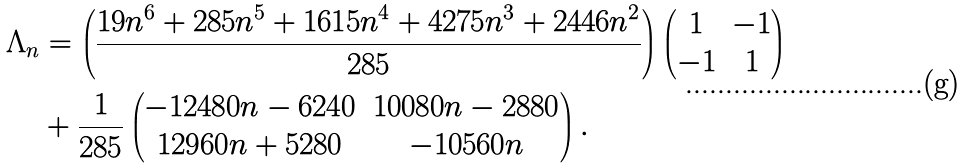Convert formula to latex. <formula><loc_0><loc_0><loc_500><loc_500>\Lambda _ { n } & = \left ( \frac { 1 9 n ^ { 6 } + 2 8 5 n ^ { 5 } + 1 6 1 5 n ^ { 4 } + 4 2 7 5 n ^ { 3 } + 2 4 4 6 n ^ { 2 } } { 2 8 5 } \right ) \begin{pmatrix} 1 & - 1 \\ - 1 & 1 \end{pmatrix} \\ & + \frac { 1 } { 2 8 5 } \begin{pmatrix} - 1 2 4 8 0 n - 6 2 4 0 & 1 0 0 8 0 n - 2 8 8 0 \\ 1 2 9 6 0 n + 5 2 8 0 & - 1 0 5 6 0 n \end{pmatrix} .</formula> 